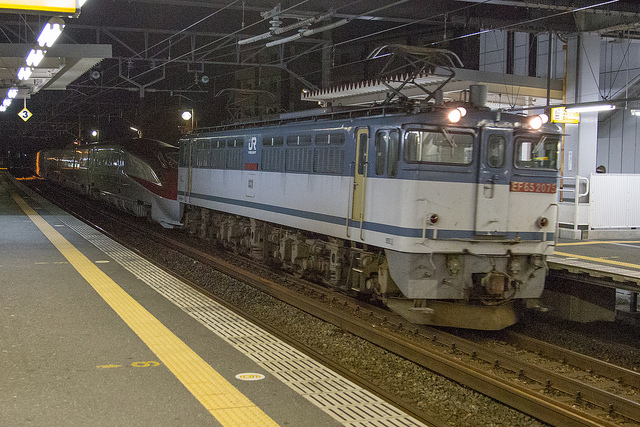Identify and read out the text in this image. EF652075 